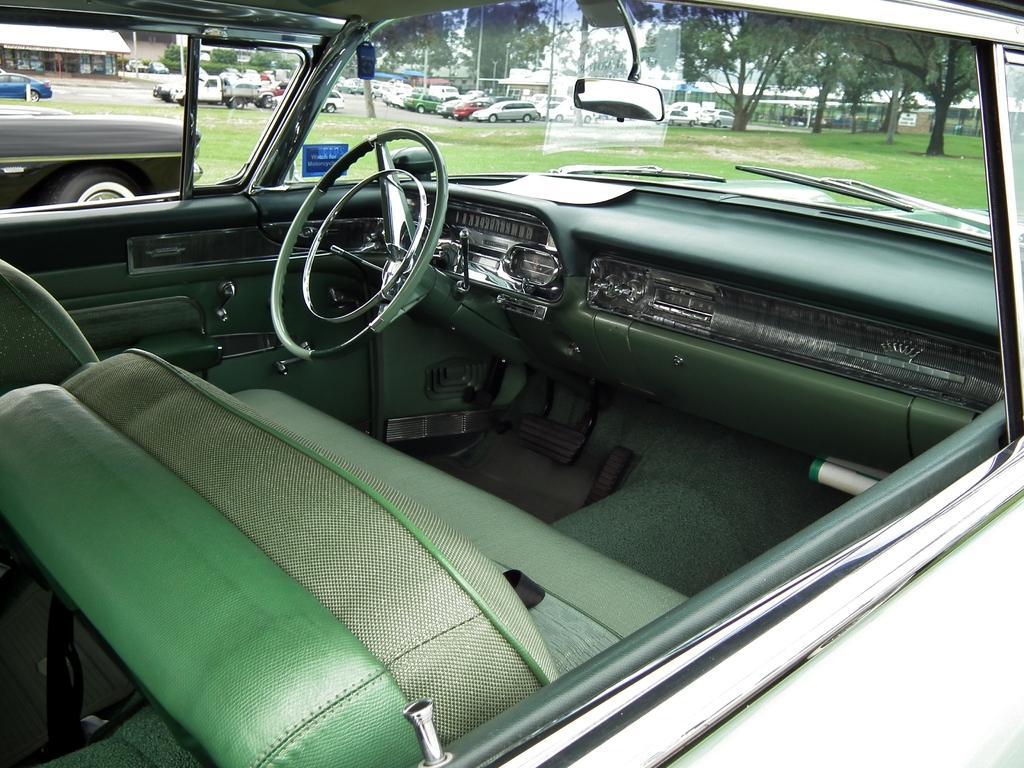How would you summarize this image in a sentence or two? In this picture we can see an inside view of a car, in the background there are some vehicles, we can see grass and trees here, on the left side there is a store. 